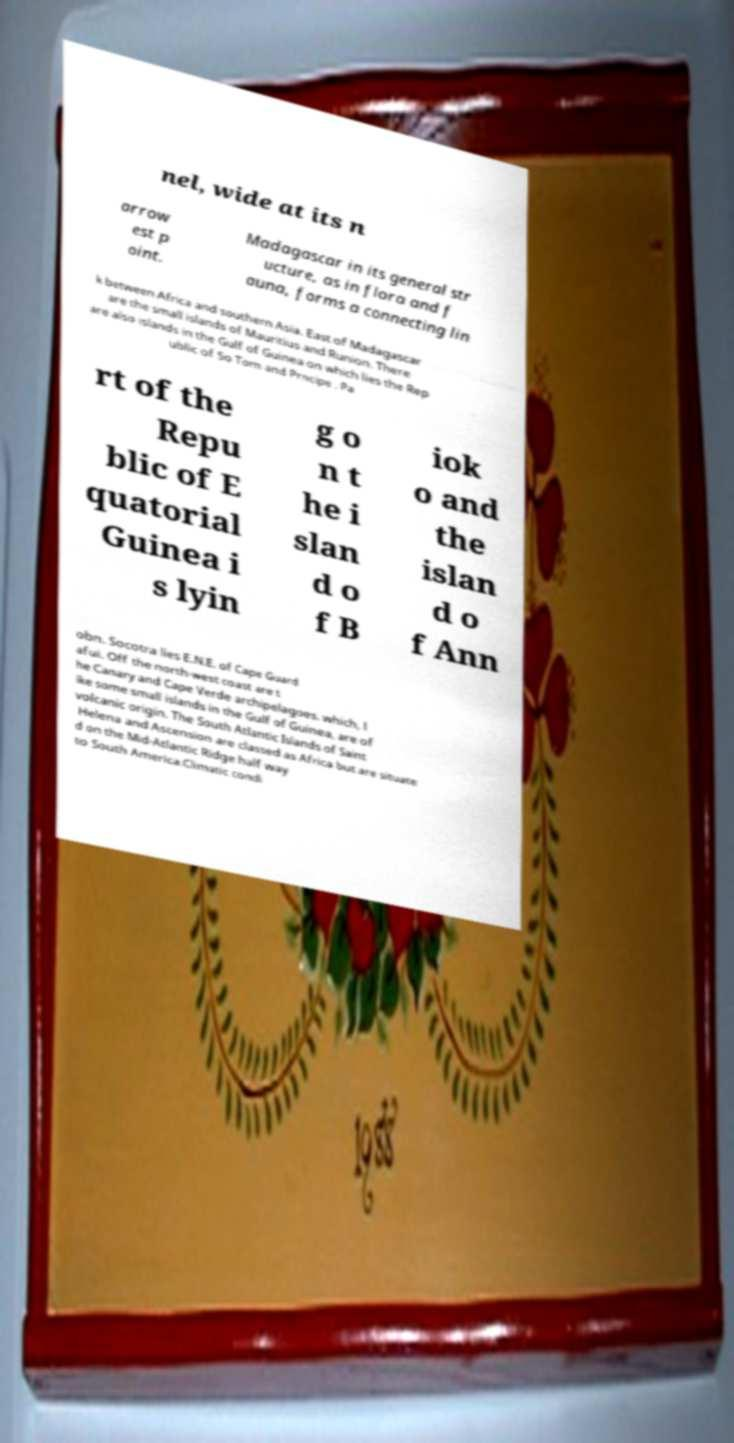There's text embedded in this image that I need extracted. Can you transcribe it verbatim? nel, wide at its n arrow est p oint. Madagascar in its general str ucture, as in flora and f auna, forms a connecting lin k between Africa and southern Asia. East of Madagascar are the small islands of Mauritius and Runion. There are also islands in the Gulf of Guinea on which lies the Rep ublic of So Tom and Prncipe . Pa rt of the Repu blic of E quatorial Guinea i s lyin g o n t he i slan d o f B iok o and the islan d o f Ann obn. Socotra lies E.N.E. of Cape Guard afui. Off the north-west coast are t he Canary and Cape Verde archipelagoes. which, l ike some small islands in the Gulf of Guinea, are of volcanic origin. The South Atlantic Islands of Saint Helena and Ascension are classed as Africa but are situate d on the Mid-Atlantic Ridge half way to South America.Climatic condi 